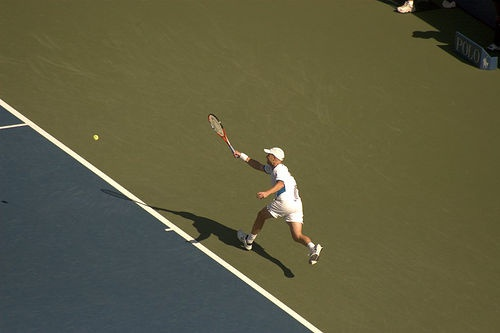Describe the objects in this image and their specific colors. I can see people in darkgreen, ivory, gray, olive, and black tones, tennis racket in darkgreen, tan, olive, gray, and brown tones, people in darkgreen, tan, black, and beige tones, and sports ball in darkgreen, olive, and khaki tones in this image. 